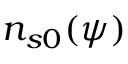<formula> <loc_0><loc_0><loc_500><loc_500>n _ { s 0 } ( \psi )</formula> 